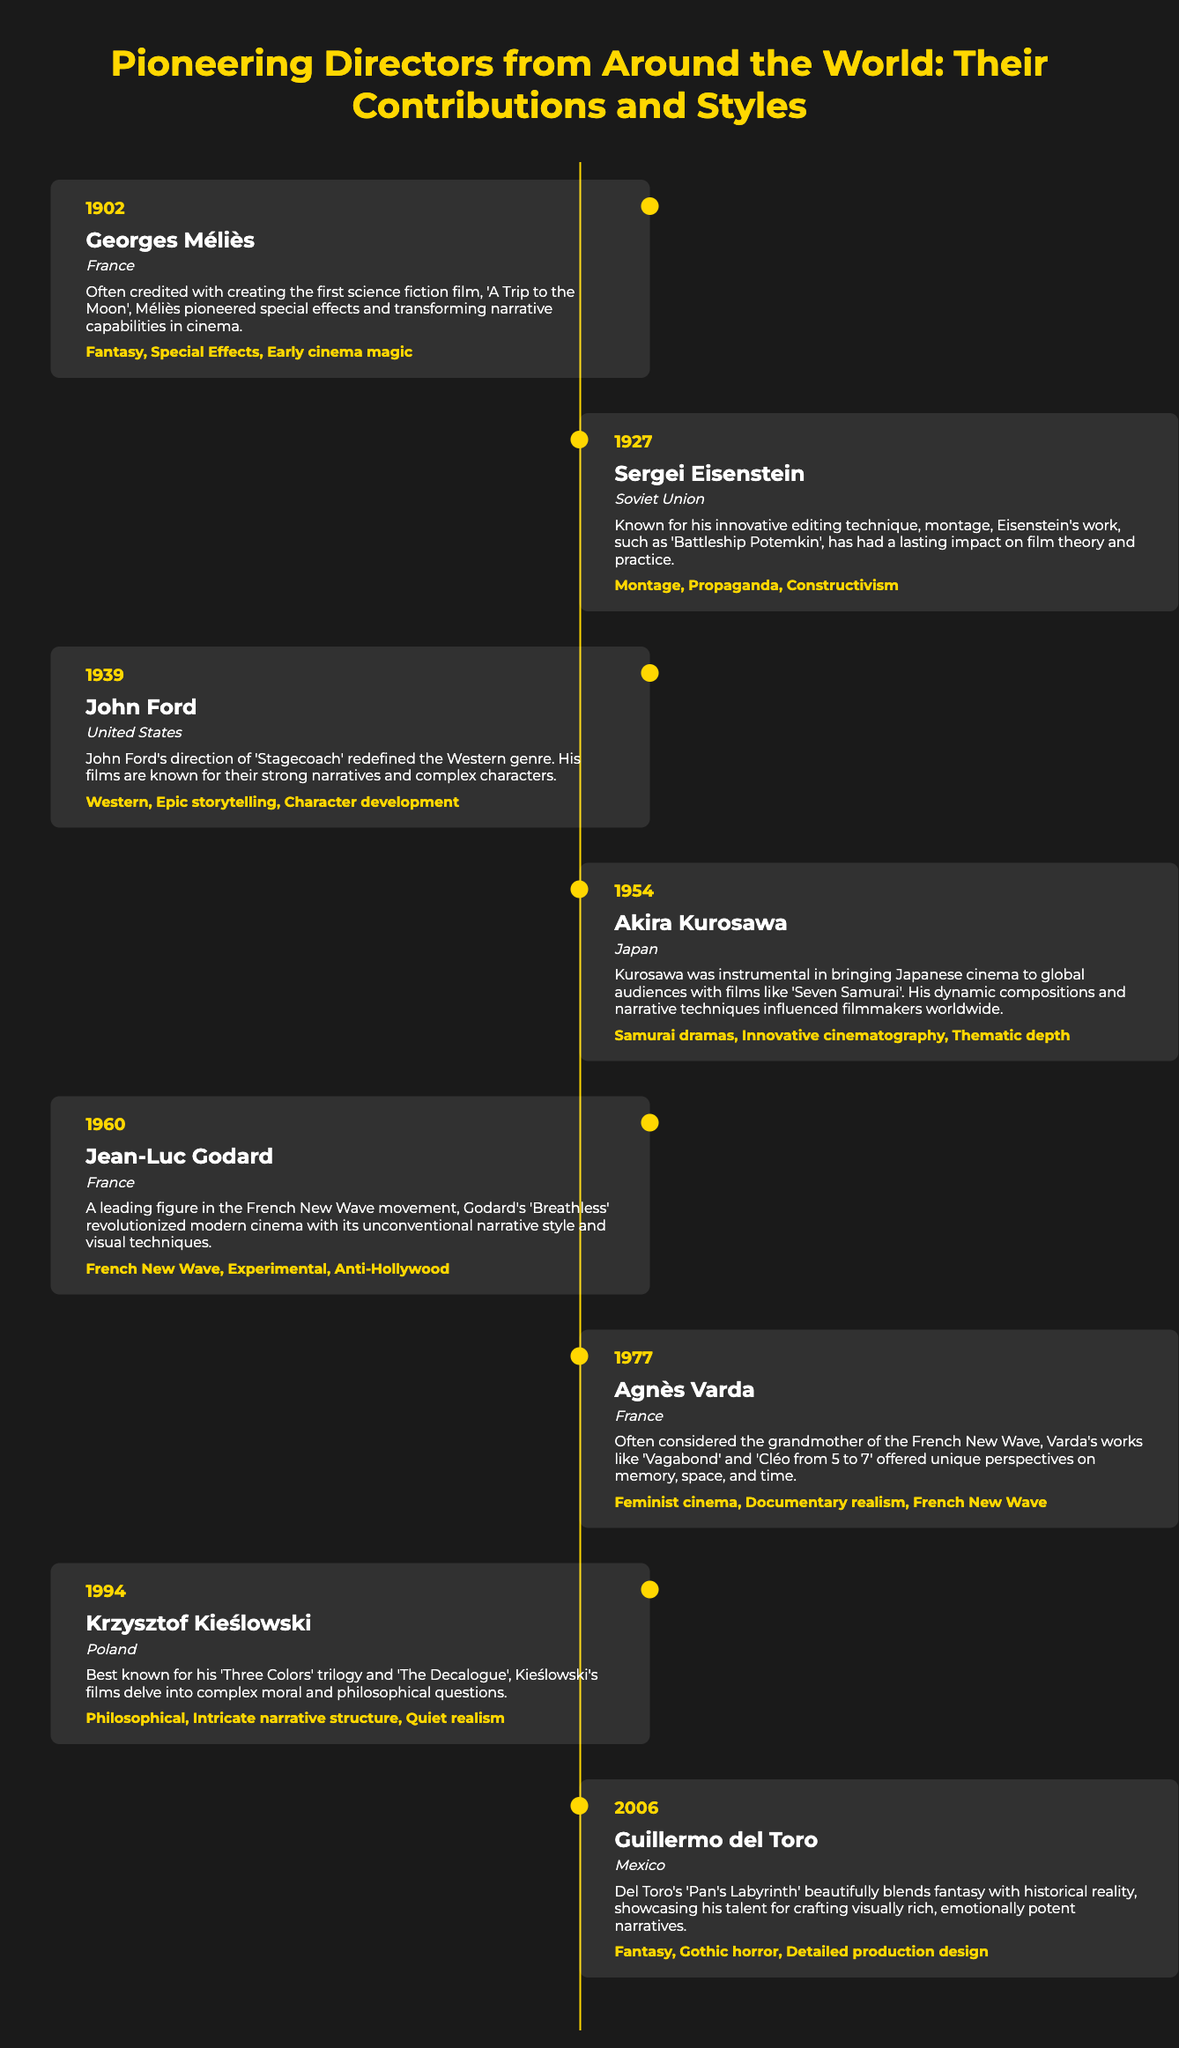What film is Georges Méliès known for? The film is mentioned in his contribution section, highlighting his pioneering work in science fiction.
Answer: A Trip to the Moon Which director pioneered the editing technique known as montage? This information is found under Sergei Eisenstein's entry, indicating his influential contributions to film theory.
Answer: Sergei Eisenstein In what year did Akira Kurosawa make significant contributions to global cinema? The year is specified in Kurosawa's timeline item, marking his impact in cinema history.
Answer: 1954 What is the primary style associated with Jean-Luc Godard? This is noted in Godard's section, showcasing his unique contributions to cinema.
Answer: French New Wave How many directors are listed in the timeline? This requires counting the total number of timeline items, which shows the count of featured directors.
Answer: 8 What genre did John Ford redefine? This information is specified in his contribution, detailing the genre he influenced through his films.
Answer: Western Which female director is highlighted as the grandmother of the French New Wave? The document explicitly states her significance within the context of that movement.
Answer: Agnès Varda What country is Krzysztof Kieślowski from? This information is provided in his timeline entry, giving insight into his nationality.
Answer: Poland 